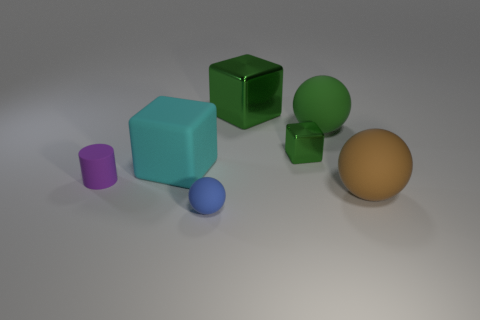Add 2 green rubber objects. How many objects exist? 9 Subtract all cylinders. How many objects are left? 6 Subtract all large brown rubber spheres. Subtract all small purple rubber things. How many objects are left? 5 Add 2 blue rubber balls. How many blue rubber balls are left? 3 Add 4 big metallic blocks. How many big metallic blocks exist? 5 Subtract 0 brown cylinders. How many objects are left? 7 